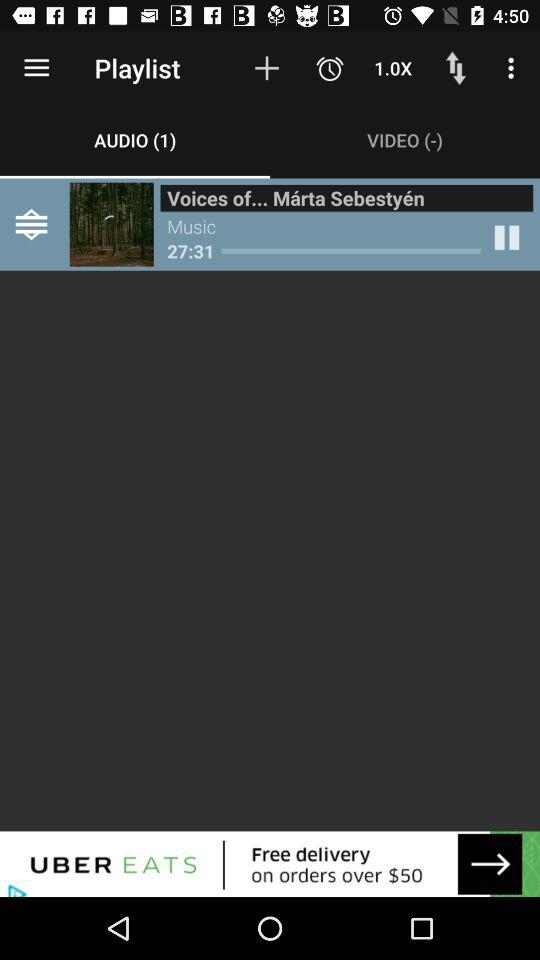How many podcasts are there? There are 50 podcasts available. 